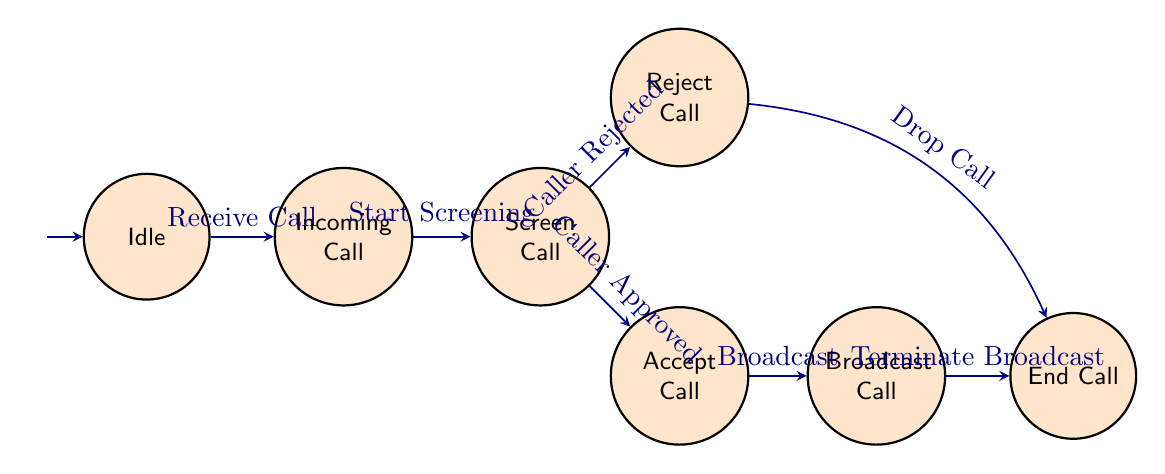What is the initial state of the system? The initial state, indicated by an arrow pointing towards the "Idle" node, shows that the system starts waiting for a call.
Answer: Idle How many states are in the diagram? Counting the nodes labeled in the diagram, we have a total of 7 states: Idle, Incoming Call, Screen Call, Accept Call, Reject Call, Broadcast Call, and End Call.
Answer: 7 What transition occurs from the "Incoming Call" state? From the "Incoming Call" state, the next transition is labeled "Start Screening," indicating the flow into screening the call.
Answer: Start Screening Which state follows "Screen Call" if the caller is rejected? If the caller is rejected, the transition from "Screen Call" to "Reject Call" occurs, indicating the rejection process is taking place.
Answer: Reject Call How many transitions are there in total? The diagram shows a total of 7 transitions, linking various states based on the call handling process.
Answer: 7 What happens after the "Broadcast Call" state? After the "Broadcast Call" state, the transition labeled "Terminate Broadcast" leads to the "End Call," which signifies the completion of the call process.
Answer: End Call What state does the system enter after "Accept Call"? After the "Accept Call" state, the transition labeled "Broadcast" directs the system to the "Broadcast Call" state, where the call is connected live to the host.
Answer: Broadcast Call What transition is required to move from "Reject Call" to "End Call"? To move from "Reject Call" to "End Call," the transition labeled "Drop Call" is required, indicating the conclusion of the call after rejection.
Answer: Drop Call 